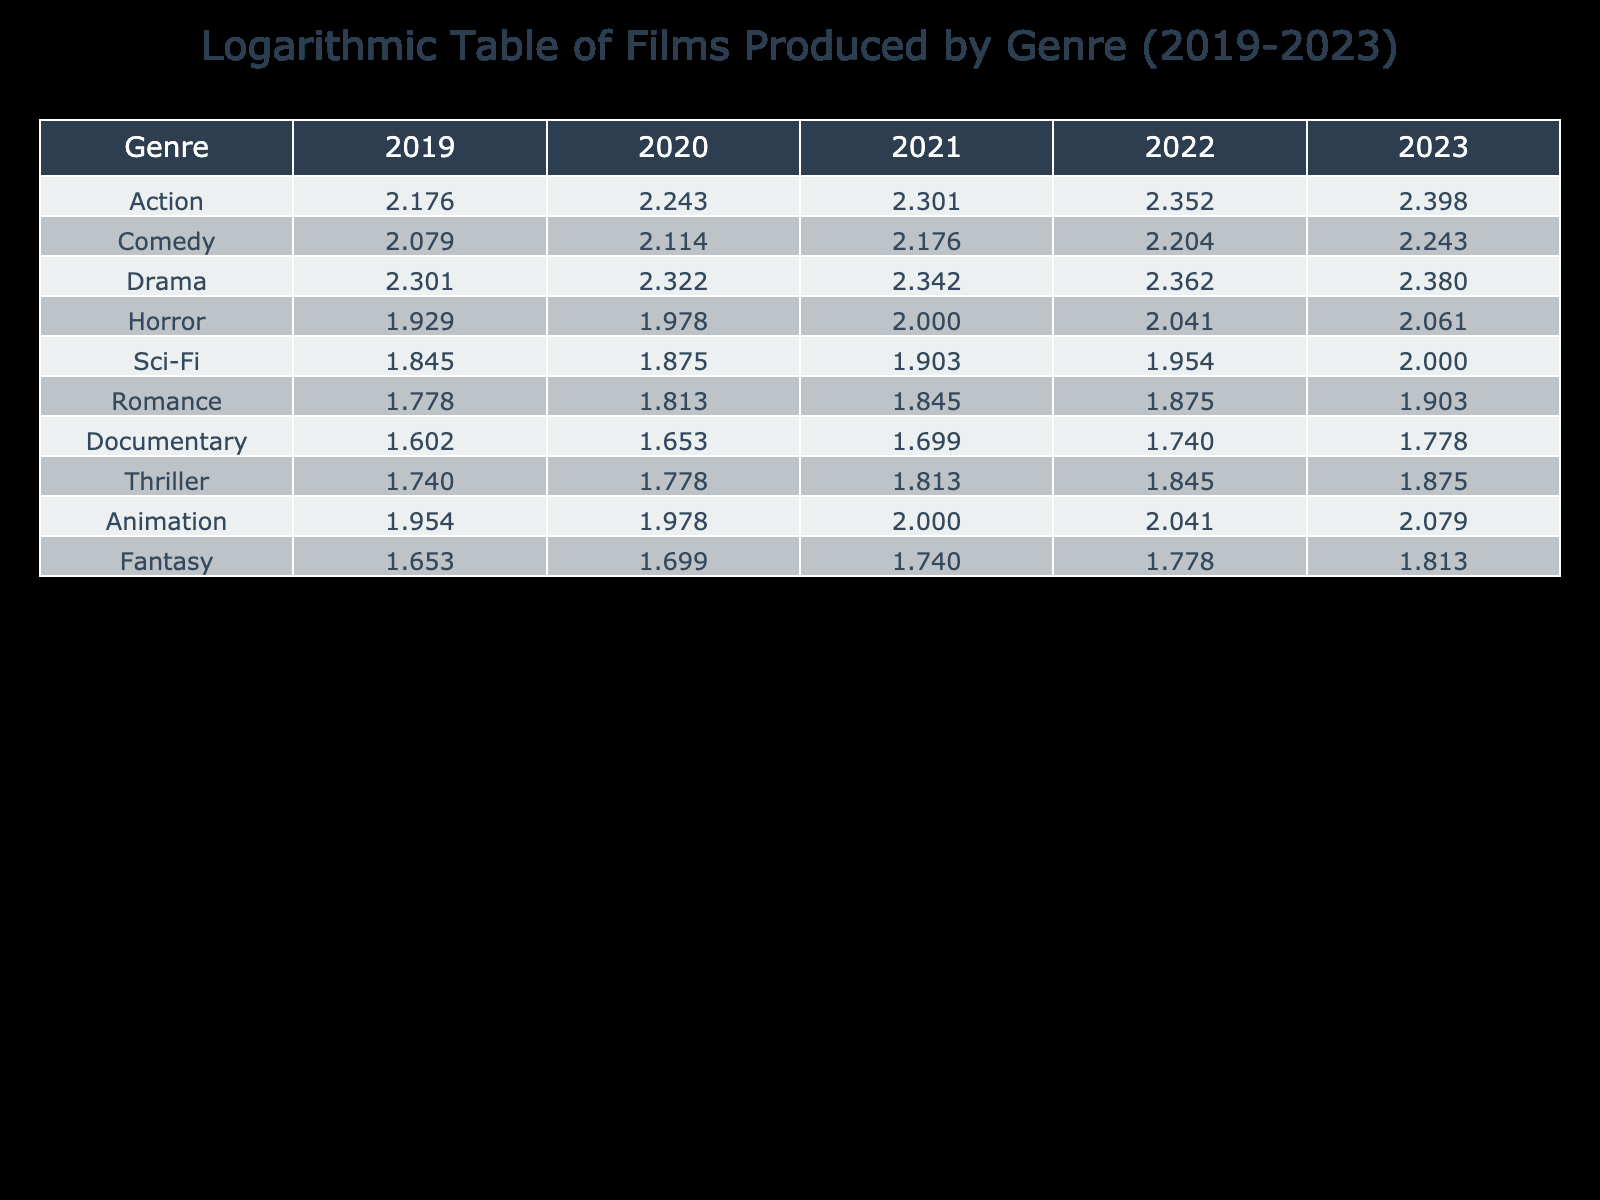What was the number of Action films produced in 2021? Looking at the 'Action' row in the table for the year 2021, the value is 200.
Answer: 200 Which genre saw the highest number of films produced in 2023? By reviewing the last column of the table for the year 2023, 'Action' has the highest count with 250 films.
Answer: Action What is the total number of Comedy and Drama films produced in 2022? To find this, we check the 'Comedy' and 'Drama' rows for 2022, which have 160 and 230 respectively. Adding those: 160 + 230 = 390.
Answer: 390 Did the number of Horror films produced increase every year from 2019 to 2023? Checking the 'Horror' row across the years, the values are 85, 95, 100, 110, and 115. Each value shows an increase from the previous year.
Answer: Yes What was the average number of Sci-Fi films produced from 2019 to 2023? The Sci-Fi films produced are 70, 75, 80, 90, and 100 over the five years. The sum is 70 + 75 + 80 + 90 + 100 = 415. Dividing this sum by 5 gives an average of 415 / 5 = 83.
Answer: 83 How many more Drama films were produced than Thriller films in 2023? The Drama films for 2023 are 240 and the Thriller films are 75. The difference is 240 - 75 = 165.
Answer: 165 What are the total films produced across all genres in 2020? Adding the values for each genre in 2020: 175 (Action) + 130 (Comedy) + 210 (Drama) + 95 (Horror) + 75 (Sci-Fi) + 65 (Romance) + 45 (Documentary) + 60 (Thriller) + 95 (Animation) + 50 (Fantasy) = 1,055.
Answer: 1055 Is the number of Animation films produced in 2022 higher than that of Horror films in the same year? For 2022, Animation films produced are 110 and Horror films are 110. Since they are equal, the statement is false.
Answer: No What is the increase in the number of Documentary films from 2019 to 2023? The number of Documentary films produced in 2019 is 40 and in 2023 it is 60. The increase is 60 - 40 = 20.
Answer: 20 What was the year-over-year growth rate for Romance films between 2022 and 2023? The Romance films in 2022 are 75 and in 2023 are 80. The growth is (80 - 75) / 75 * 100 = 6.67%.
Answer: 6.67% 